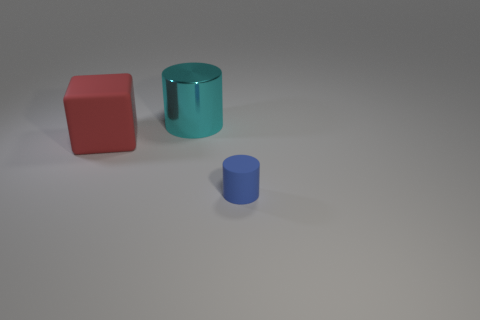Add 1 large red rubber cubes. How many objects exist? 4 Subtract all cylinders. How many objects are left? 1 Subtract 0 blue spheres. How many objects are left? 3 Subtract all large matte balls. Subtract all big cyan things. How many objects are left? 2 Add 1 large things. How many large things are left? 3 Add 2 small gray metallic spheres. How many small gray metallic spheres exist? 2 